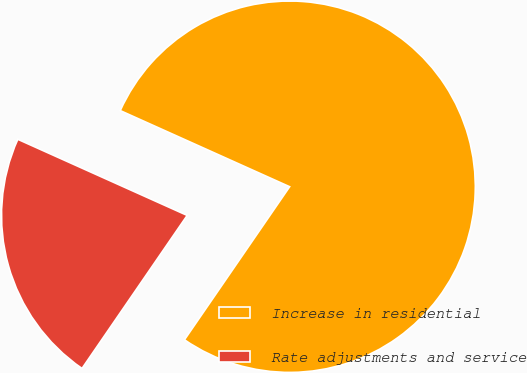Convert chart to OTSL. <chart><loc_0><loc_0><loc_500><loc_500><pie_chart><fcel>Increase in residential<fcel>Rate adjustments and service<nl><fcel>77.86%<fcel>22.14%<nl></chart> 